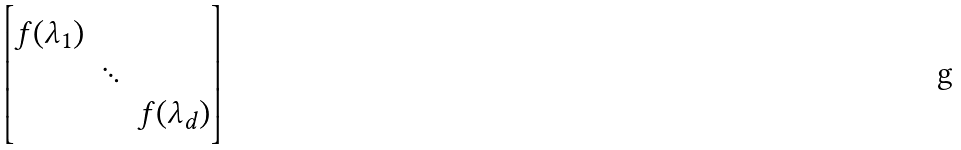Convert formula to latex. <formula><loc_0><loc_0><loc_500><loc_500>\begin{bmatrix} f ( \lambda _ { 1 } ) \\ & \ddots \\ & & f ( \lambda _ { d } ) \end{bmatrix}</formula> 